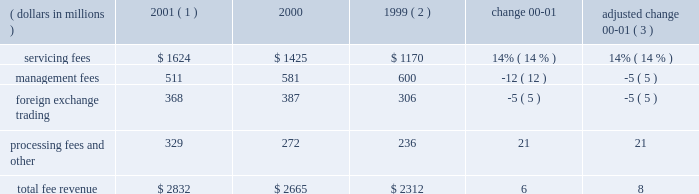An average of 7.1 in 2000 .
The top 100 largest clients used an average of 11.3 products in 2001 , up from an average of 11.2 in 2000 .
State street benefits significantly from its ability to derive revenue from the transaction flows of clients .
This occurs through the management of cash positions , including deposit balances and other short-term investment activities , using state street 2019s balance sheet capacity .
Significant foreign currency transaction volumes provide potential for foreign exchange trading revenue as well .
Fee revenue total operating fee revenuewas $ 2.8 billion in 2001 , compared to $ 2.7 billion in 2000 , an increase of 6% ( 6 % ) .
Adjusted for the formation of citistreet , the growth in fee revenue was 8% ( 8 % ) .
Growth in servicing fees of $ 199million , or 14% ( 14 % ) , was the primary contributor to the increase in fee revenue .
This growth primarily reflects several large client wins installed starting in the latter half of 2000 and continuing throughout 2001 , and strength in fee revenue from securities lending .
Declines in equity market values worldwide offset some of the growth in servicing fees .
Management fees were down 5% ( 5 % ) , adjusted for the formation of citistreet , reflecting the decline in theworldwide equitymarkets .
Foreign exchange trading revenue was down 5% ( 5 % ) , reflecting lower currency volatility , and processing fees and other revenue was up 21% ( 21 % ) , primarily due to gains on the sales of investment securities .
Servicing and management fees are a function of several factors , including the mix and volume of assets under custody and assets under management , securities positions held , and portfolio transactions , as well as types of products and services used by clients .
State street estimates , based on a study conducted in 2000 , that a 10% ( 10 % ) increase or decrease in worldwide equity values would cause a corresponding change in state street 2019s total revenue of approximately 2% ( 2 % ) .
If bond values were to increase or decrease by 10% ( 10 % ) , state street would anticipate a corresponding change of approximately 1% ( 1 % ) in its total revenue .
Securities lending revenue in 2001 increased approximately 40% ( 40 % ) over 2000 .
Securities lending revenue is reflected in both servicing fees and management fees .
Securities lending revenue is a function of the volume of securities lent and interest rate spreads .
While volumes increased in 2001 , the year-over-year increase is primarily due to wider interest rate spreads resulting from the unusual occurrence of eleven reductions in the u.s .
Federal funds target rate during 2001 .
F e e r e v e n u e ( dollars in millions ) 2001 ( 1 ) 2000 1999 ( 2 ) change adjusted change 00-01 ( 3 ) .
( 1 ) 2001 results exclude the write-off of state street 2019s total investment in bridge of $ 50 million ( 2 ) 1999 results exclude the one-time charge of $ 57 million related to the repositioning of the investment portfolio ( 3 ) 2000 results adjusted for the formation of citistreet 4 state street corporation .
What percent of the total fee revenue in 2001 was from servicing fees? 
Computations: (1624 / 2832)
Answer: 0.57345. 